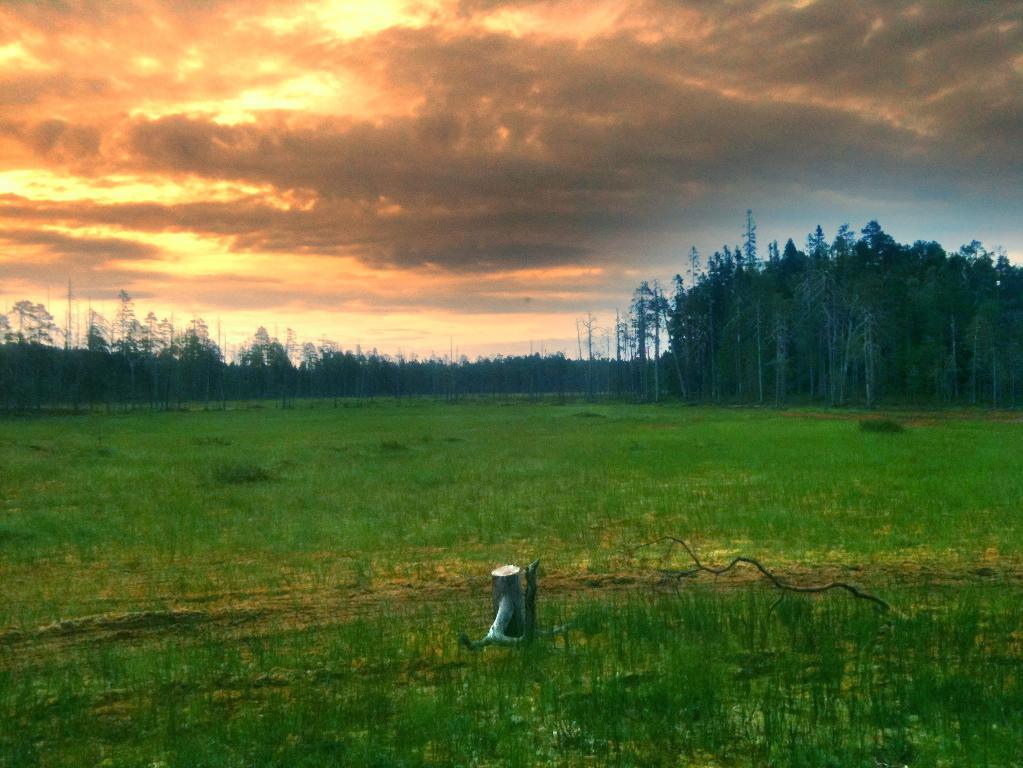Describe this image in one or two sentences. In this picture we can see the sky and it seems like a cloudy day. We can see trees and green grass. We can see a branch and an object , it seems like a water pump at the bottom. 